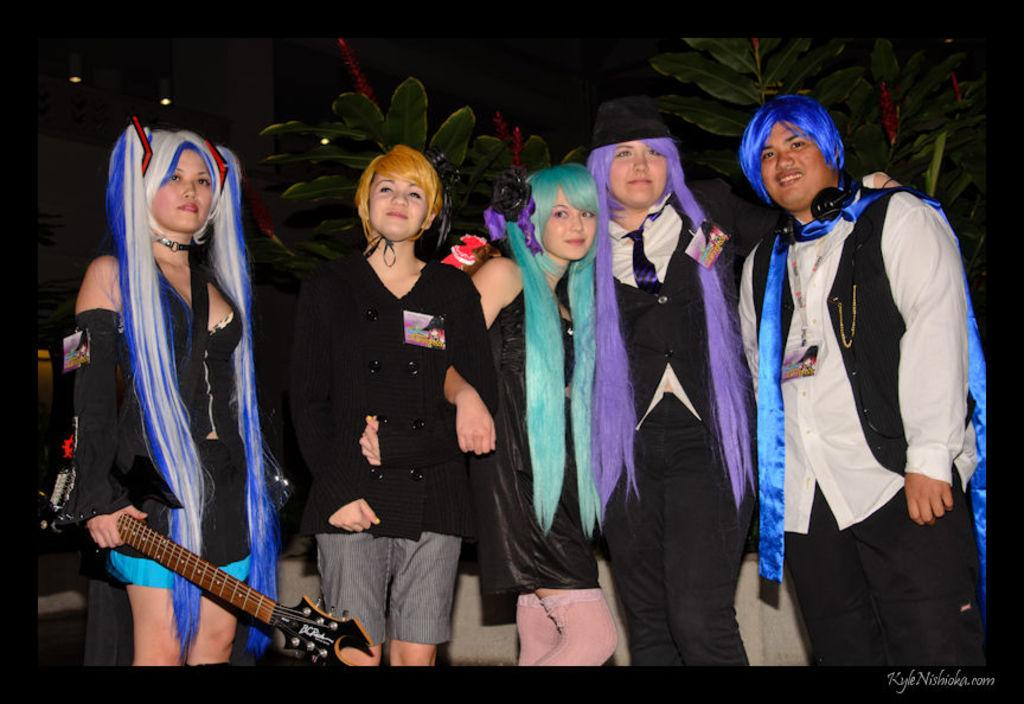What is the main subject of the image? The main subject of the image is a group of people. What are the people in the image doing? The people are standing and smiling. Can you describe any specific person in the group? Yes, there is a woman in the group who is holding a guitar. What type of seashore can be seen in the background of the image? There is no seashore present in the image; it features a group of people standing and smiling. What answer is the woman providing to the question asked by the man in the image? There is no conversation or question-and-answer exchange depicted in the image. 